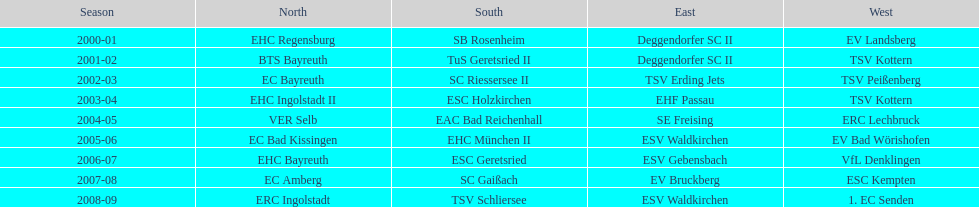Who won the season in the north before ec bayreuth did in 2002-03? BTS Bayreuth. 